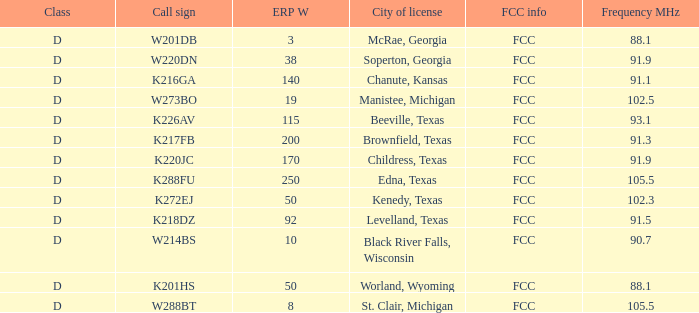What is the Sum of ERP W, when Call Sign is K216GA? 140.0. 